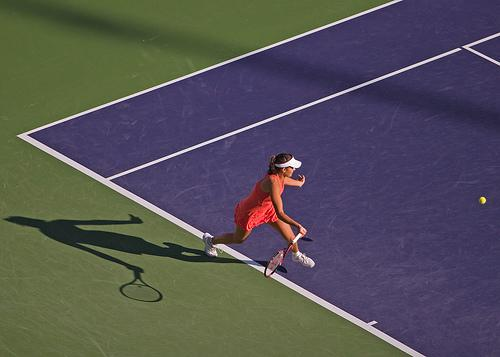Question: what is this lady doing?
Choices:
A. Playing basketball.
B. Reading a book.
C. Writing a poem.
D. Playing tennis.
Answer with the letter. Answer: D Question: why is this lady running so hard?
Choices:
A. To throw a ball.
B. To burn calories.
C. To exercise.
D. To catch the ball.
Answer with the letter. Answer: D Question: what is the color of the ball?
Choices:
A. Red.
B. Blue.
C. Green.
D. Orange.
Answer with the letter. Answer: C Question: who is this lady?
Choices:
A. A baseball player.
B. A basketball player.
C. A tennis player.
D. A surfer.
Answer with the letter. Answer: C Question: when is this lady going to hit the ball?
Choices:
A. As soon as the ball gets close enough.
B. When the ball bounces.
C. When she sees it.
D. In a few hours.
Answer with the letter. Answer: A Question: what is the color of the tennis court?
Choices:
A. Blue.
B. Green.
C. Yellow.
D. Grey.
Answer with the letter. Answer: A Question: where is this lady?
Choices:
A. On a basketball court.
B. In a car.
C. In a library.
D. In a tennis court.
Answer with the letter. Answer: D 